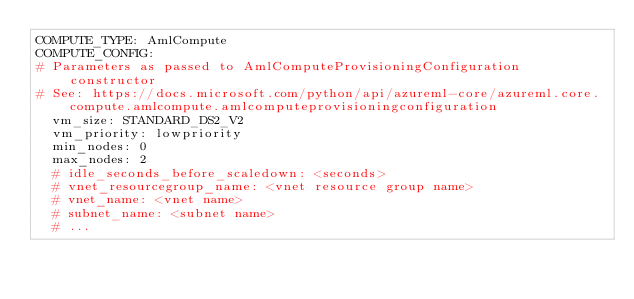Convert code to text. <code><loc_0><loc_0><loc_500><loc_500><_YAML_>COMPUTE_TYPE: AmlCompute
COMPUTE_CONFIG:
# Parameters as passed to AmlComputeProvisioningConfiguration constructor
# See: https://docs.microsoft.com/python/api/azureml-core/azureml.core.compute.amlcompute.amlcomputeprovisioningconfiguration
  vm_size: STANDARD_DS2_V2
  vm_priority: lowpriority
  min_nodes: 0
  max_nodes: 2
  # idle_seconds_before_scaledown: <seconds>
  # vnet_resourcegroup_name: <vnet resource group name>
  # vnet_name: <vnet name>
  # subnet_name: <subnet name>
  # ...
</code> 